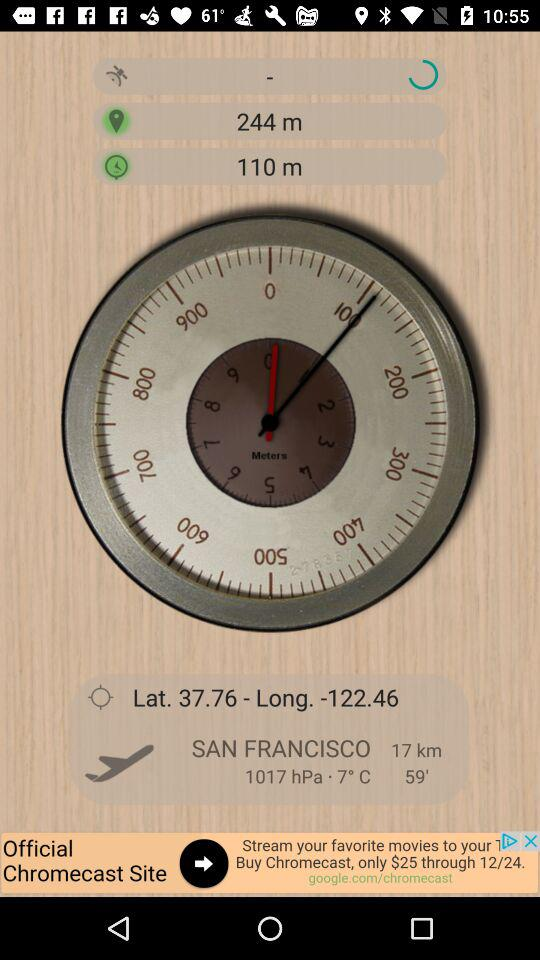What is the temperature? The temperature is 7° Celsius. 